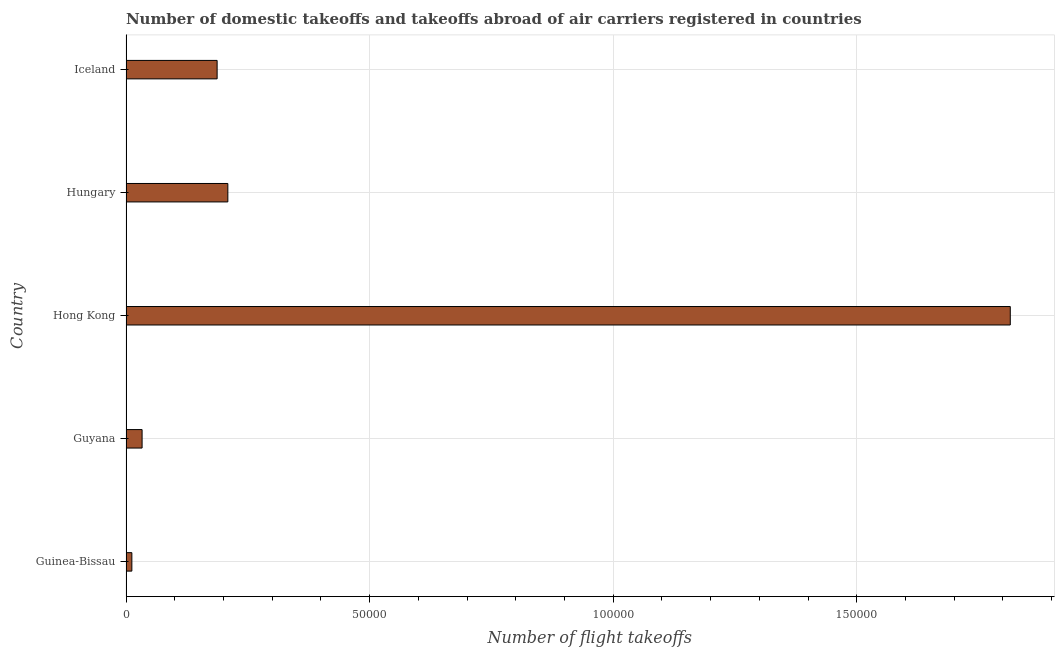Does the graph contain any zero values?
Ensure brevity in your answer.  No. Does the graph contain grids?
Your answer should be very brief. Yes. What is the title of the graph?
Make the answer very short. Number of domestic takeoffs and takeoffs abroad of air carriers registered in countries. What is the label or title of the X-axis?
Give a very brief answer. Number of flight takeoffs. What is the label or title of the Y-axis?
Offer a very short reply. Country. What is the number of flight takeoffs in Guinea-Bissau?
Provide a short and direct response. 1200. Across all countries, what is the maximum number of flight takeoffs?
Your response must be concise. 1.82e+05. Across all countries, what is the minimum number of flight takeoffs?
Your response must be concise. 1200. In which country was the number of flight takeoffs maximum?
Offer a terse response. Hong Kong. In which country was the number of flight takeoffs minimum?
Make the answer very short. Guinea-Bissau. What is the sum of the number of flight takeoffs?
Ensure brevity in your answer.  2.26e+05. What is the difference between the number of flight takeoffs in Guinea-Bissau and Hong Kong?
Keep it short and to the point. -1.80e+05. What is the average number of flight takeoffs per country?
Ensure brevity in your answer.  4.51e+04. What is the median number of flight takeoffs?
Your response must be concise. 1.87e+04. What is the ratio of the number of flight takeoffs in Hong Kong to that in Hungary?
Provide a succinct answer. 8.68. Is the number of flight takeoffs in Guinea-Bissau less than that in Guyana?
Your answer should be compact. Yes. Is the difference between the number of flight takeoffs in Hong Kong and Hungary greater than the difference between any two countries?
Provide a succinct answer. No. What is the difference between the highest and the second highest number of flight takeoffs?
Your answer should be very brief. 1.61e+05. Is the sum of the number of flight takeoffs in Guyana and Hong Kong greater than the maximum number of flight takeoffs across all countries?
Offer a very short reply. Yes. What is the difference between the highest and the lowest number of flight takeoffs?
Provide a short and direct response. 1.80e+05. What is the difference between two consecutive major ticks on the X-axis?
Your response must be concise. 5.00e+04. Are the values on the major ticks of X-axis written in scientific E-notation?
Provide a short and direct response. No. What is the Number of flight takeoffs of Guinea-Bissau?
Provide a short and direct response. 1200. What is the Number of flight takeoffs in Guyana?
Make the answer very short. 3300. What is the Number of flight takeoffs in Hong Kong?
Offer a terse response. 1.82e+05. What is the Number of flight takeoffs in Hungary?
Your answer should be very brief. 2.09e+04. What is the Number of flight takeoffs in Iceland?
Your answer should be very brief. 1.87e+04. What is the difference between the Number of flight takeoffs in Guinea-Bissau and Guyana?
Offer a terse response. -2100. What is the difference between the Number of flight takeoffs in Guinea-Bissau and Hong Kong?
Your response must be concise. -1.80e+05. What is the difference between the Number of flight takeoffs in Guinea-Bissau and Hungary?
Give a very brief answer. -1.97e+04. What is the difference between the Number of flight takeoffs in Guinea-Bissau and Iceland?
Your answer should be compact. -1.75e+04. What is the difference between the Number of flight takeoffs in Guyana and Hong Kong?
Ensure brevity in your answer.  -1.78e+05. What is the difference between the Number of flight takeoffs in Guyana and Hungary?
Provide a succinct answer. -1.76e+04. What is the difference between the Number of flight takeoffs in Guyana and Iceland?
Ensure brevity in your answer.  -1.54e+04. What is the difference between the Number of flight takeoffs in Hong Kong and Hungary?
Offer a terse response. 1.61e+05. What is the difference between the Number of flight takeoffs in Hong Kong and Iceland?
Keep it short and to the point. 1.63e+05. What is the difference between the Number of flight takeoffs in Hungary and Iceland?
Your answer should be compact. 2200. What is the ratio of the Number of flight takeoffs in Guinea-Bissau to that in Guyana?
Provide a short and direct response. 0.36. What is the ratio of the Number of flight takeoffs in Guinea-Bissau to that in Hong Kong?
Offer a very short reply. 0.01. What is the ratio of the Number of flight takeoffs in Guinea-Bissau to that in Hungary?
Make the answer very short. 0.06. What is the ratio of the Number of flight takeoffs in Guinea-Bissau to that in Iceland?
Offer a very short reply. 0.06. What is the ratio of the Number of flight takeoffs in Guyana to that in Hong Kong?
Give a very brief answer. 0.02. What is the ratio of the Number of flight takeoffs in Guyana to that in Hungary?
Keep it short and to the point. 0.16. What is the ratio of the Number of flight takeoffs in Guyana to that in Iceland?
Make the answer very short. 0.18. What is the ratio of the Number of flight takeoffs in Hong Kong to that in Hungary?
Your response must be concise. 8.68. What is the ratio of the Number of flight takeoffs in Hong Kong to that in Iceland?
Offer a very short reply. 9.71. What is the ratio of the Number of flight takeoffs in Hungary to that in Iceland?
Provide a succinct answer. 1.12. 